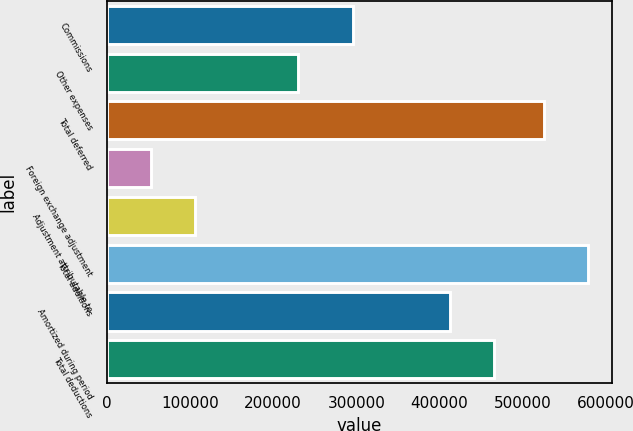<chart> <loc_0><loc_0><loc_500><loc_500><bar_chart><fcel>Commissions<fcel>Other expenses<fcel>Total deferred<fcel>Foreign exchange adjustment<fcel>Adjustment attributable to<fcel>Total additions<fcel>Amortized during period<fcel>Total deductions<nl><fcel>296043<fcel>229367<fcel>525410<fcel>53048.4<fcel>106093<fcel>578454<fcel>413114<fcel>466158<nl></chart> 